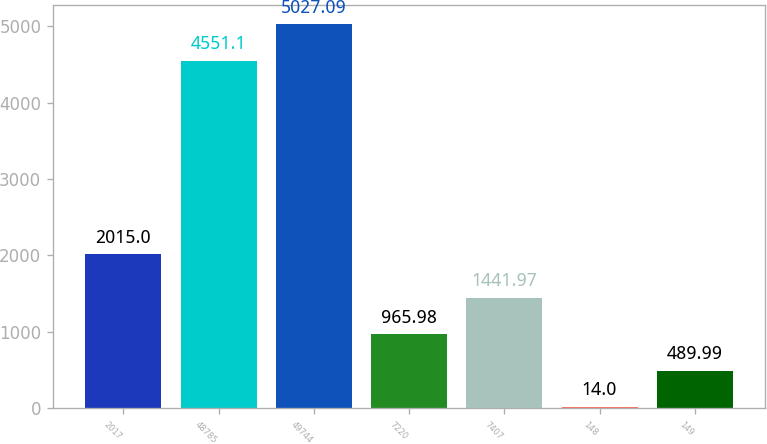Convert chart to OTSL. <chart><loc_0><loc_0><loc_500><loc_500><bar_chart><fcel>2017<fcel>48785<fcel>49744<fcel>7220<fcel>7407<fcel>148<fcel>149<nl><fcel>2015<fcel>4551.1<fcel>5027.09<fcel>965.98<fcel>1441.97<fcel>14<fcel>489.99<nl></chart> 